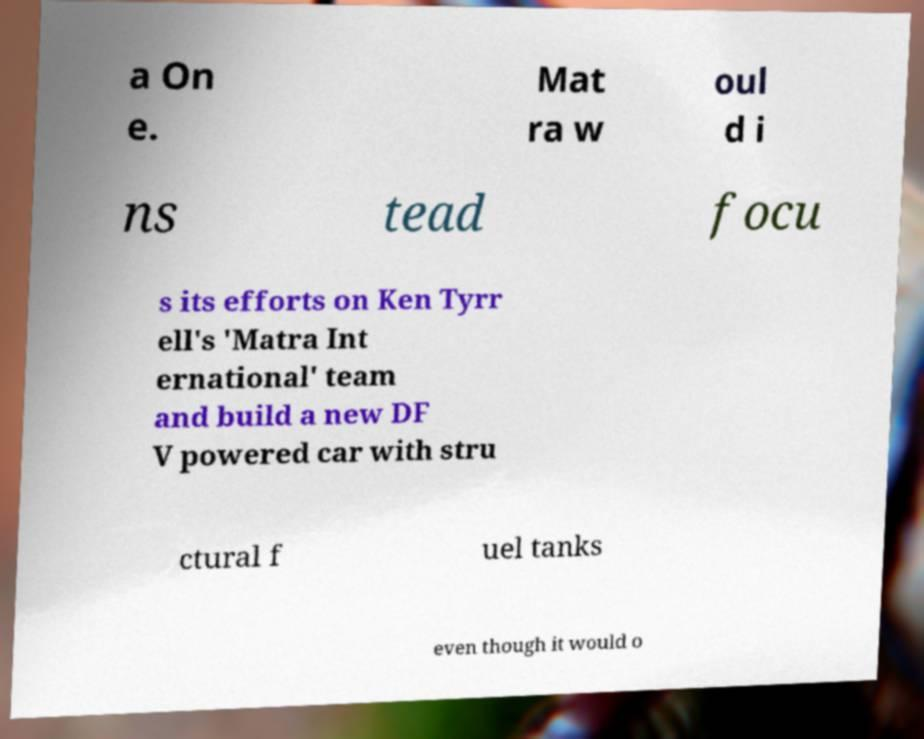Could you assist in decoding the text presented in this image and type it out clearly? a On e. Mat ra w oul d i ns tead focu s its efforts on Ken Tyrr ell's 'Matra Int ernational' team and build a new DF V powered car with stru ctural f uel tanks even though it would o 